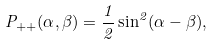Convert formula to latex. <formula><loc_0><loc_0><loc_500><loc_500>P _ { + + } ( \alpha , \beta ) = \frac { 1 } { 2 } \sin ^ { 2 } ( \alpha - \beta ) ,</formula> 